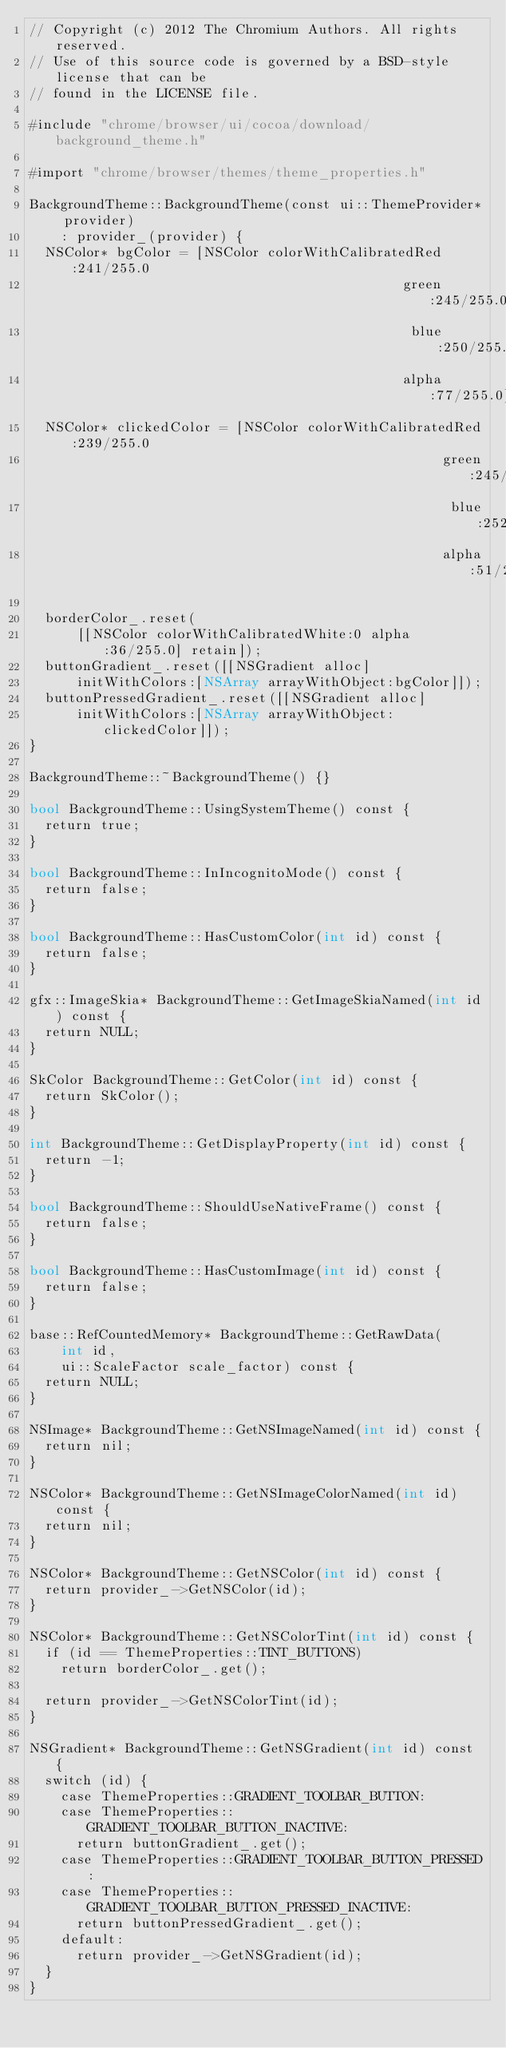<code> <loc_0><loc_0><loc_500><loc_500><_ObjectiveC_>// Copyright (c) 2012 The Chromium Authors. All rights reserved.
// Use of this source code is governed by a BSD-style license that can be
// found in the LICENSE file.

#include "chrome/browser/ui/cocoa/download/background_theme.h"

#import "chrome/browser/themes/theme_properties.h"

BackgroundTheme::BackgroundTheme(const ui::ThemeProvider* provider)
    : provider_(provider) {
  NSColor* bgColor = [NSColor colorWithCalibratedRed:241/255.0
                                               green:245/255.0
                                                blue:250/255.0
                                               alpha:77/255.0];
  NSColor* clickedColor = [NSColor colorWithCalibratedRed:239/255.0
                                                    green:245/255.0
                                                     blue:252/255.0
                                                    alpha:51/255.0];

  borderColor_.reset(
      [[NSColor colorWithCalibratedWhite:0 alpha:36/255.0] retain]);
  buttonGradient_.reset([[NSGradient alloc]
      initWithColors:[NSArray arrayWithObject:bgColor]]);
  buttonPressedGradient_.reset([[NSGradient alloc]
      initWithColors:[NSArray arrayWithObject:clickedColor]]);
}

BackgroundTheme::~BackgroundTheme() {}

bool BackgroundTheme::UsingSystemTheme() const {
  return true;
}

bool BackgroundTheme::InIncognitoMode() const {
  return false;
}

bool BackgroundTheme::HasCustomColor(int id) const {
  return false;
}

gfx::ImageSkia* BackgroundTheme::GetImageSkiaNamed(int id) const {
  return NULL;
}

SkColor BackgroundTheme::GetColor(int id) const {
  return SkColor();
}

int BackgroundTheme::GetDisplayProperty(int id) const {
  return -1;
}

bool BackgroundTheme::ShouldUseNativeFrame() const {
  return false;
}

bool BackgroundTheme::HasCustomImage(int id) const {
  return false;
}

base::RefCountedMemory* BackgroundTheme::GetRawData(
    int id,
    ui::ScaleFactor scale_factor) const {
  return NULL;
}

NSImage* BackgroundTheme::GetNSImageNamed(int id) const {
  return nil;
}

NSColor* BackgroundTheme::GetNSImageColorNamed(int id) const {
  return nil;
}

NSColor* BackgroundTheme::GetNSColor(int id) const {
  return provider_->GetNSColor(id);
}

NSColor* BackgroundTheme::GetNSColorTint(int id) const {
  if (id == ThemeProperties::TINT_BUTTONS)
    return borderColor_.get();

  return provider_->GetNSColorTint(id);
}

NSGradient* BackgroundTheme::GetNSGradient(int id) const {
  switch (id) {
    case ThemeProperties::GRADIENT_TOOLBAR_BUTTON:
    case ThemeProperties::GRADIENT_TOOLBAR_BUTTON_INACTIVE:
      return buttonGradient_.get();
    case ThemeProperties::GRADIENT_TOOLBAR_BUTTON_PRESSED:
    case ThemeProperties::GRADIENT_TOOLBAR_BUTTON_PRESSED_INACTIVE:
      return buttonPressedGradient_.get();
    default:
      return provider_->GetNSGradient(id);
  }
}
</code> 